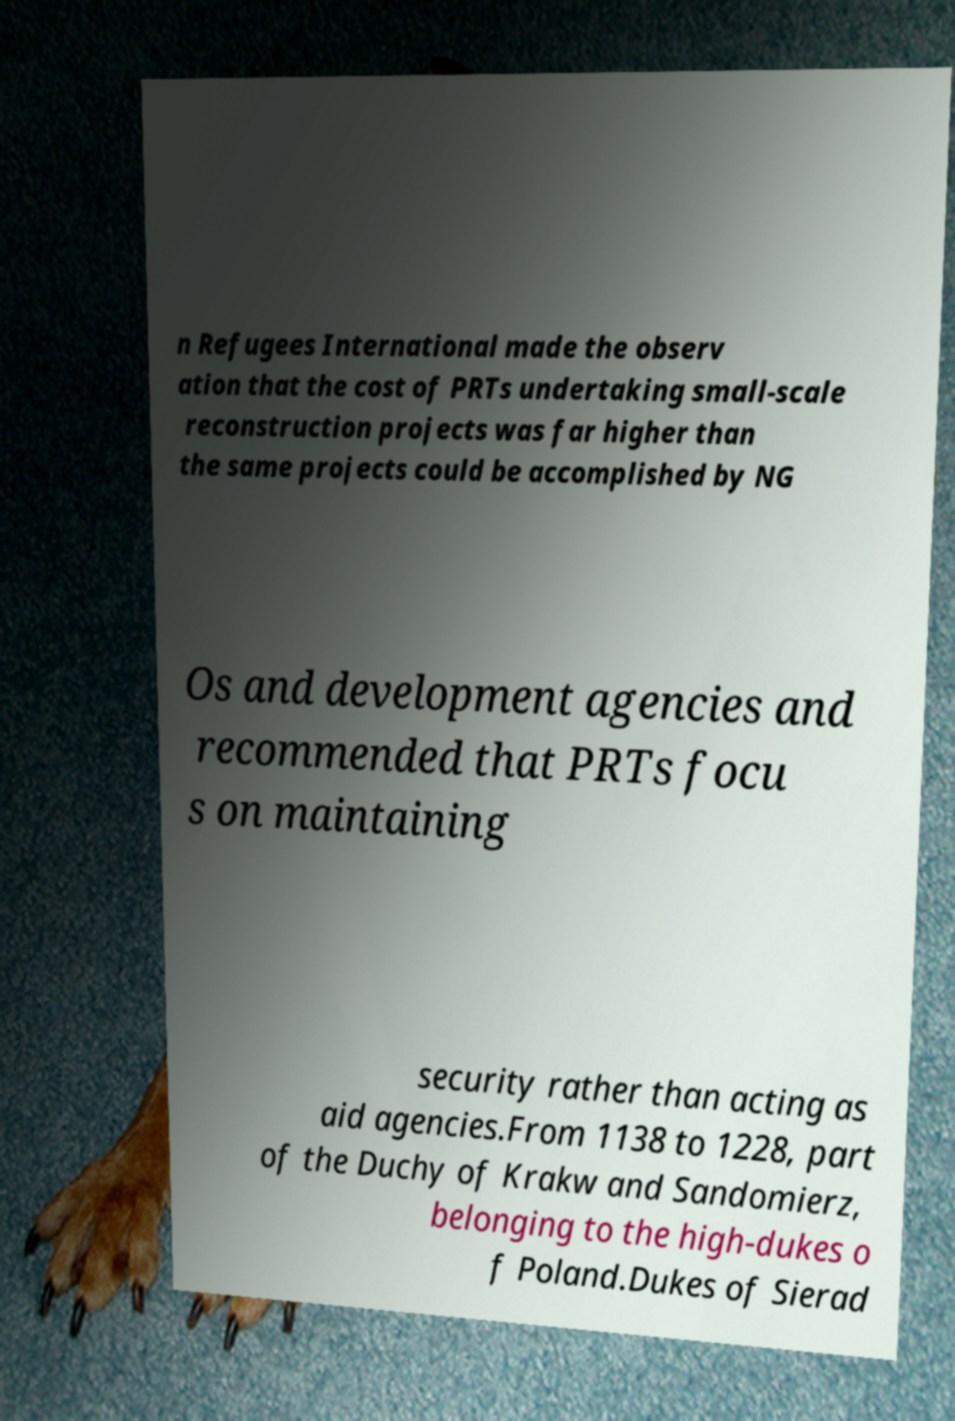Please read and relay the text visible in this image. What does it say? n Refugees International made the observ ation that the cost of PRTs undertaking small-scale reconstruction projects was far higher than the same projects could be accomplished by NG Os and development agencies and recommended that PRTs focu s on maintaining security rather than acting as aid agencies.From 1138 to 1228, part of the Duchy of Krakw and Sandomierz, belonging to the high-dukes o f Poland.Dukes of Sierad 